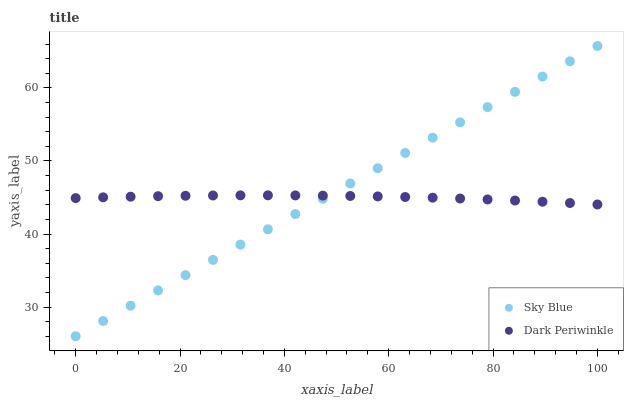Does Dark Periwinkle have the minimum area under the curve?
Answer yes or no. Yes. Does Sky Blue have the maximum area under the curve?
Answer yes or no. Yes. Does Dark Periwinkle have the maximum area under the curve?
Answer yes or no. No. Is Sky Blue the smoothest?
Answer yes or no. Yes. Is Dark Periwinkle the roughest?
Answer yes or no. Yes. Is Dark Periwinkle the smoothest?
Answer yes or no. No. Does Sky Blue have the lowest value?
Answer yes or no. Yes. Does Dark Periwinkle have the lowest value?
Answer yes or no. No. Does Sky Blue have the highest value?
Answer yes or no. Yes. Does Dark Periwinkle have the highest value?
Answer yes or no. No. Does Sky Blue intersect Dark Periwinkle?
Answer yes or no. Yes. Is Sky Blue less than Dark Periwinkle?
Answer yes or no. No. Is Sky Blue greater than Dark Periwinkle?
Answer yes or no. No. 